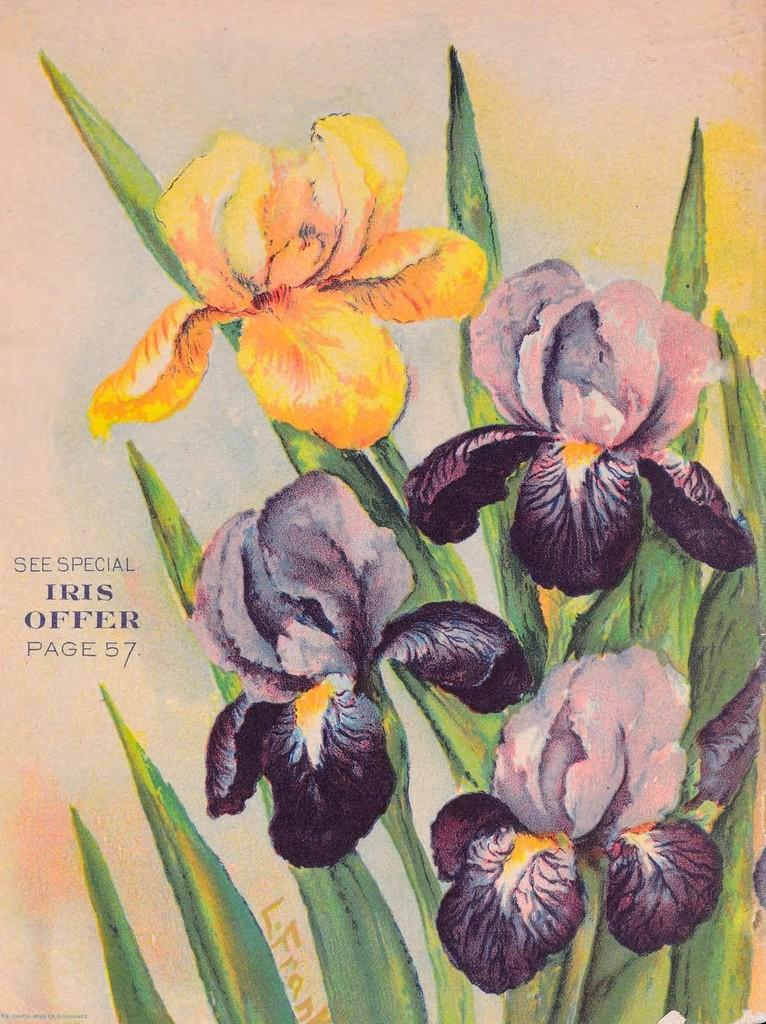What is depicted in the painting in the image? There is a painting of flowers in the image. What else can be seen on the left side of the image? There is something written on the left side of the image. What type of teeth can be seen in the painting of flowers? There are no teeth present in the painting of flowers; it depicts flowers. 